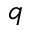Convert formula to latex. <formula><loc_0><loc_0><loc_500><loc_500>q</formula> 